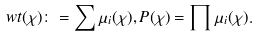Convert formula to latex. <formula><loc_0><loc_0><loc_500><loc_500>\ w t ( \chi ) \colon = \sum \mu _ { i } ( \chi ) , P ( \chi ) = \prod \mu _ { i } ( \chi ) .</formula> 